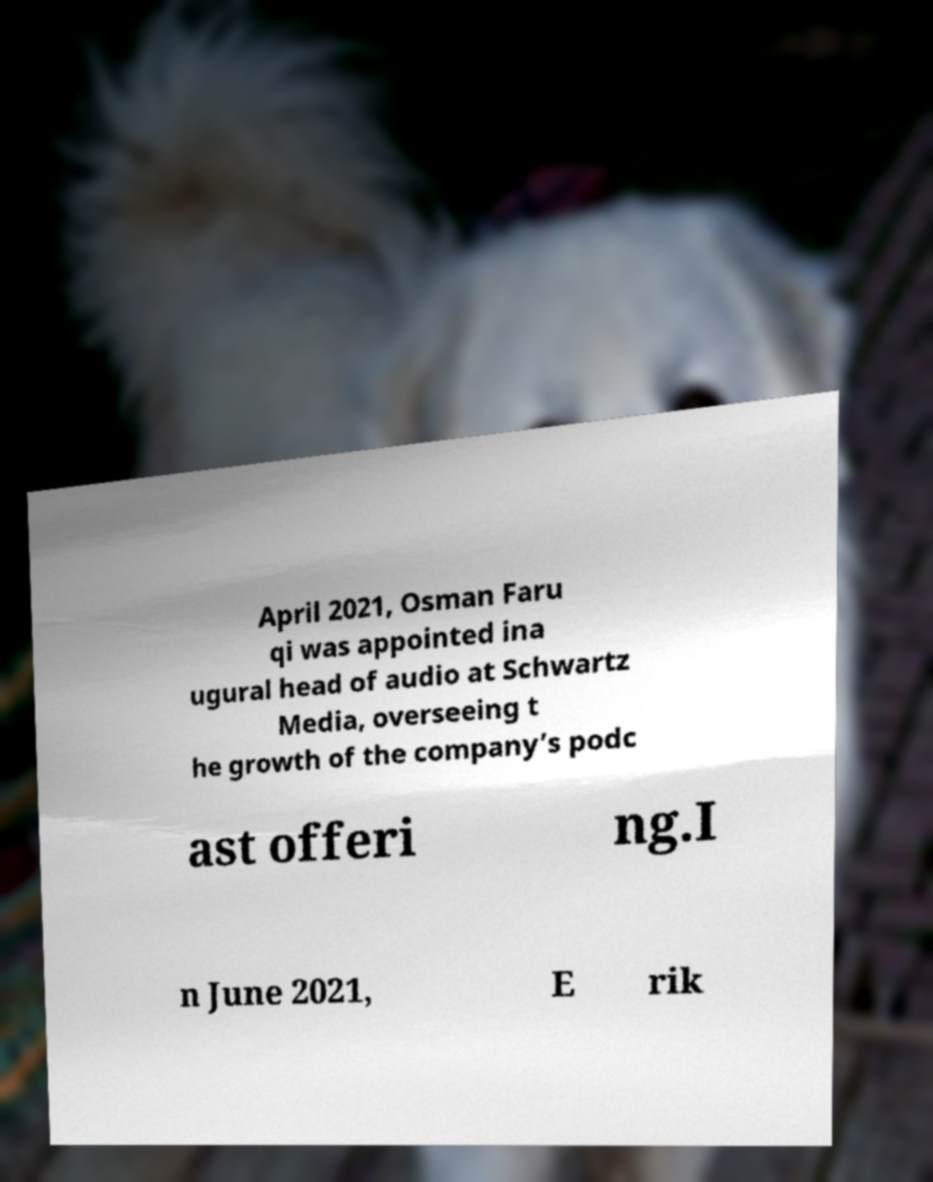Can you accurately transcribe the text from the provided image for me? April 2021, Osman Faru qi was appointed ina ugural head of audio at Schwartz Media, overseeing t he growth of the company’s podc ast offeri ng.I n June 2021, E rik 